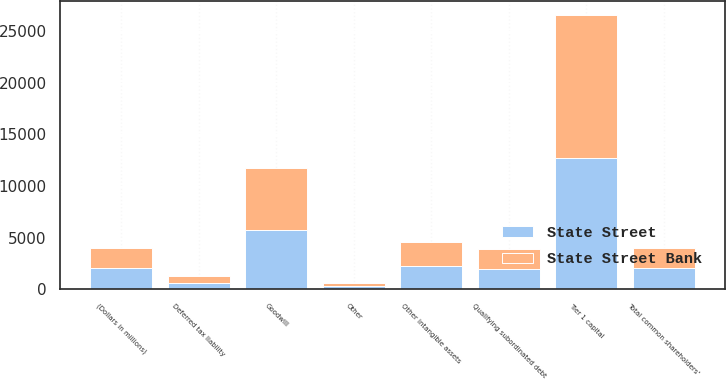Convert chart to OTSL. <chart><loc_0><loc_0><loc_500><loc_500><stacked_bar_chart><ecel><fcel>(Dollars in millions)<fcel>Total common shareholders'<fcel>Goodwill<fcel>Other intangible assets<fcel>Deferred tax liability<fcel>Other<fcel>Tier 1 capital<fcel>Qualifying subordinated debt<nl><fcel>State Street Bank<fcel>2013<fcel>2013<fcel>6036<fcel>2360<fcel>653<fcel>310<fcel>13895<fcel>1918<nl><fcel>State Street<fcel>2013<fcel>2013<fcel>5740<fcel>2239<fcel>638<fcel>304<fcel>12718<fcel>1936<nl></chart> 